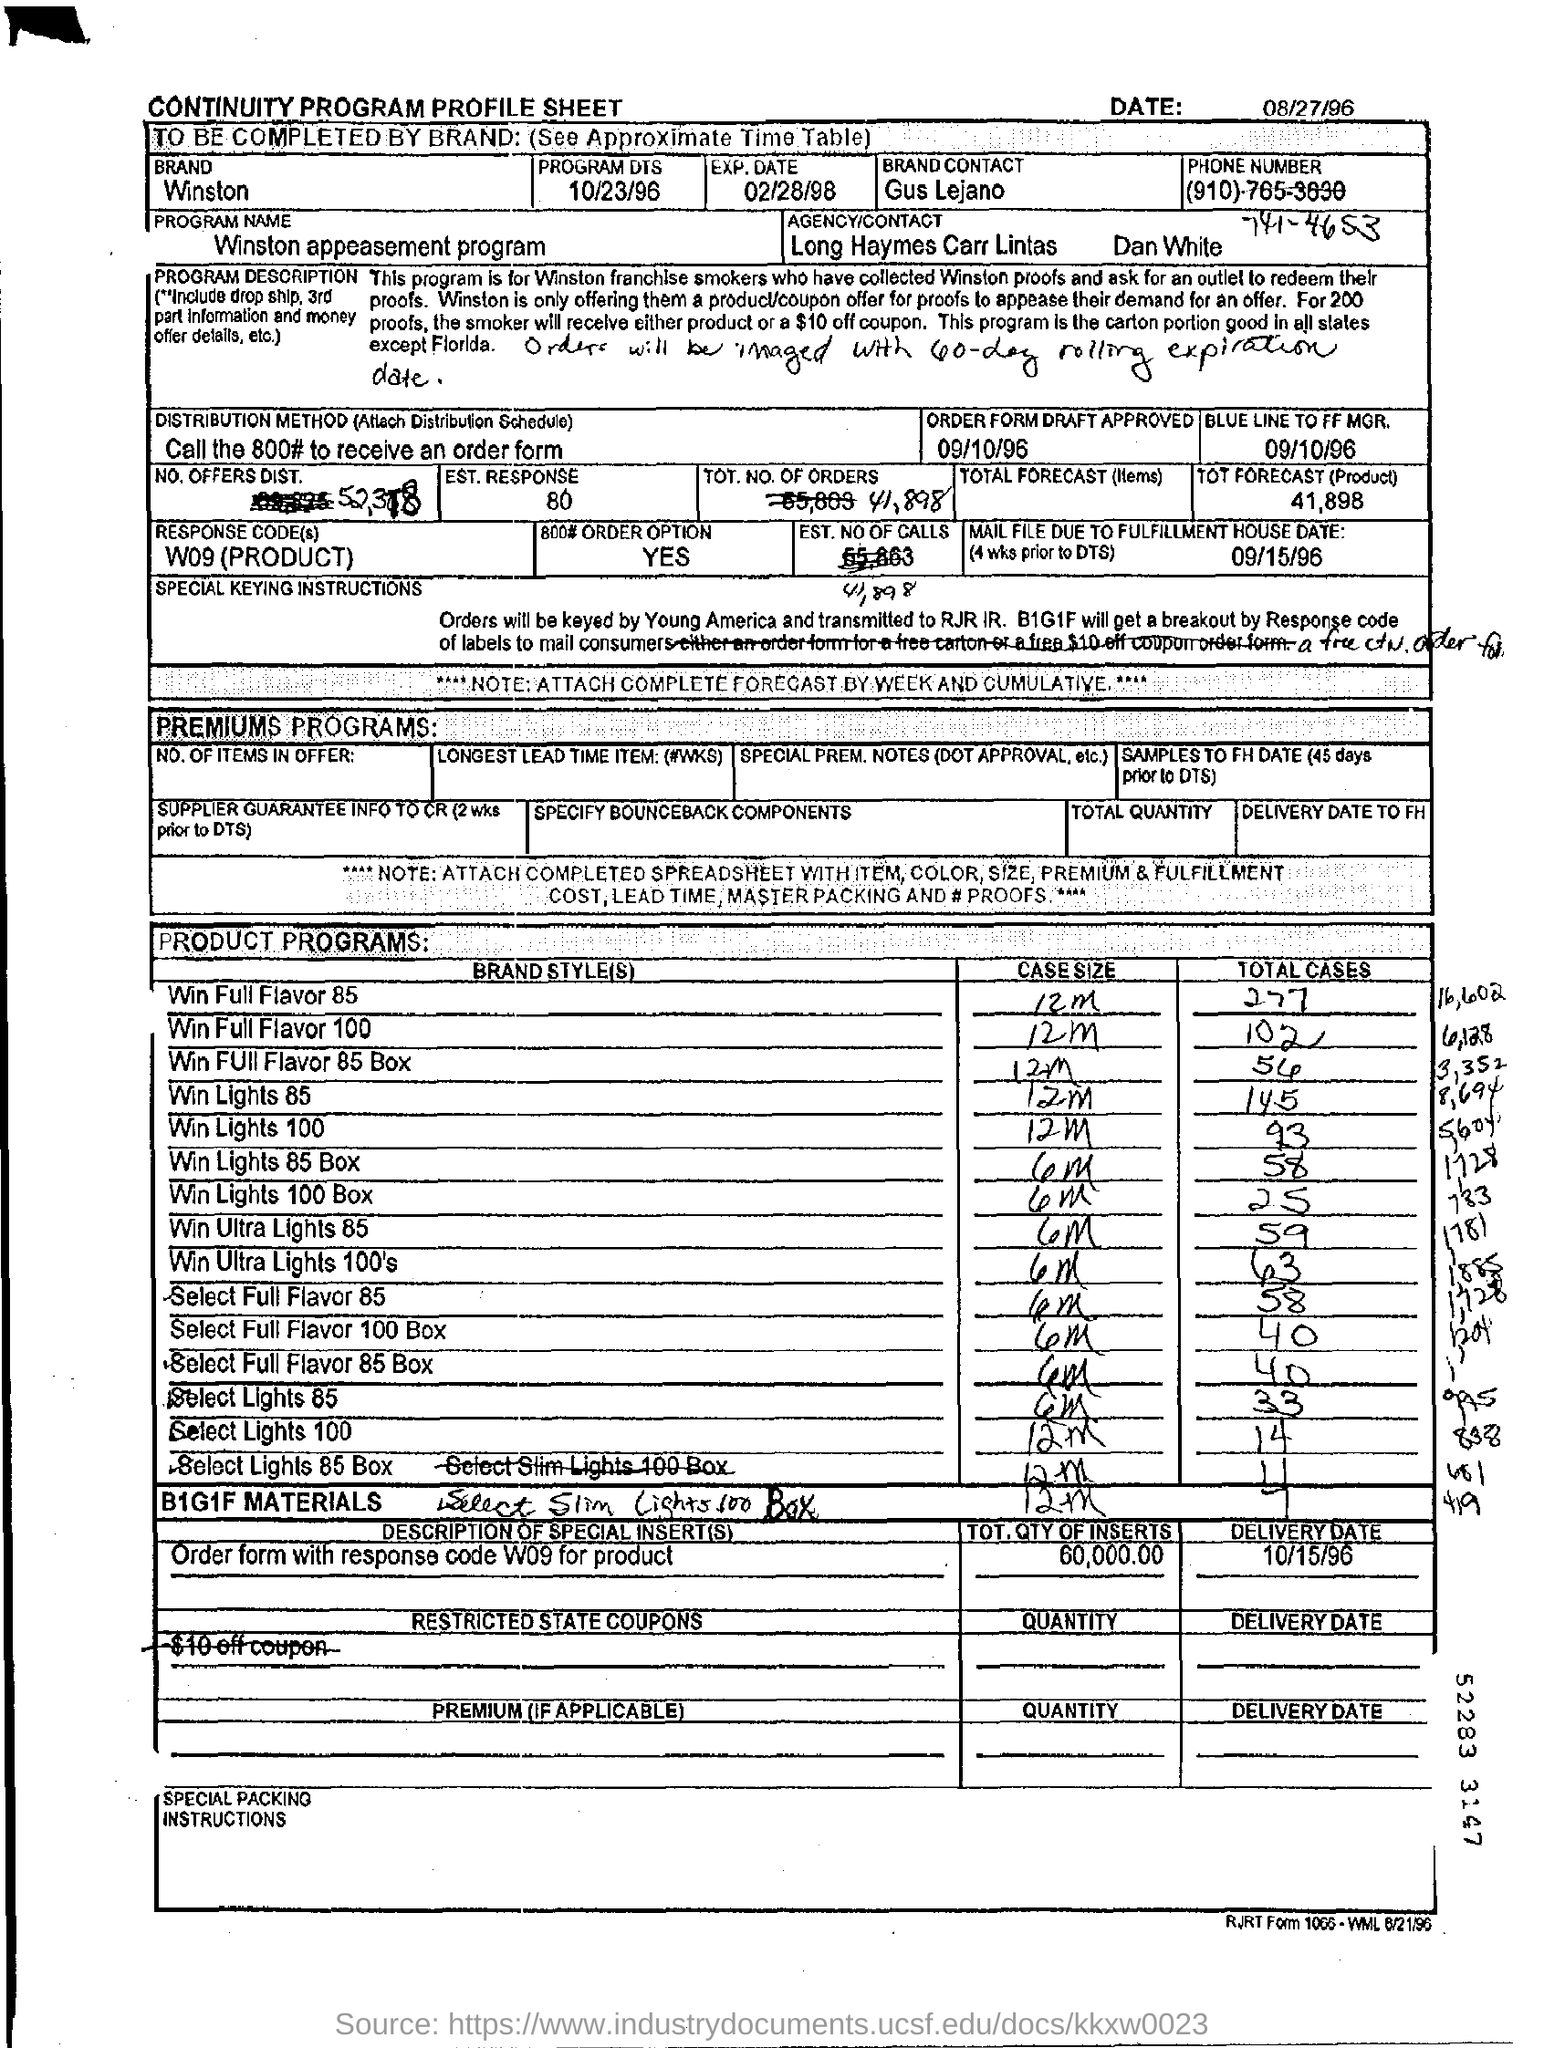Mention a couple of crucial points in this snapshot. The response code field indicates that the product is mentioned. The brand field contains the written word 'Winston.' The date mentioned at the top of the document is August 27, 1996. The program name is "Winston appeasement program. The case size of Win Full Flavor 100 is 12 millimeters. 